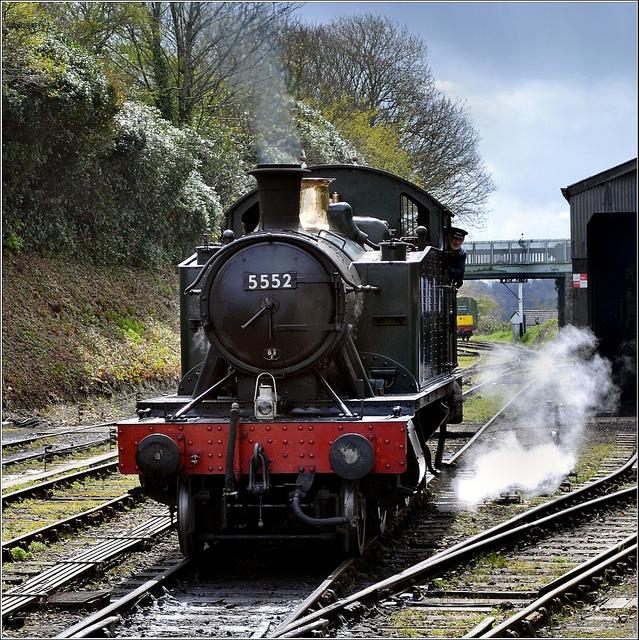When was the first steam engine put into use?
Quick response, please. 1698. How fast is the train going?
Be succinct. Fast. What number is on the front of the train?
Answer briefly. 5552. Is there any smoke in the picture?
Write a very short answer. Yes. 